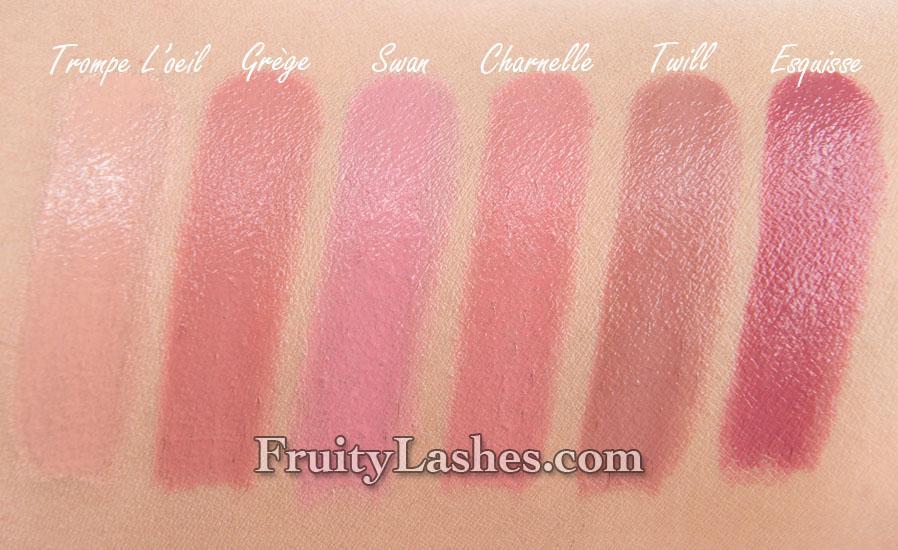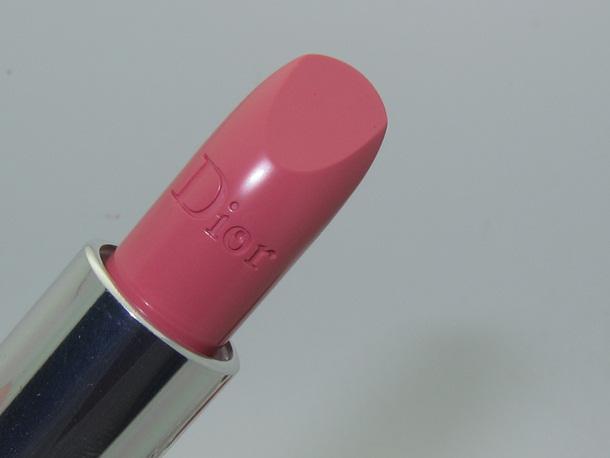The first image is the image on the left, the second image is the image on the right. Given the left and right images, does the statement "One of the images shows a single lipstick on display and the other shows a group of at least three lipsticks." hold true? Answer yes or no. No. The first image is the image on the left, the second image is the image on the right. Analyze the images presented: Is the assertion "there is a single tuble of lipstick with a black cap next to it" valid? Answer yes or no. No. 